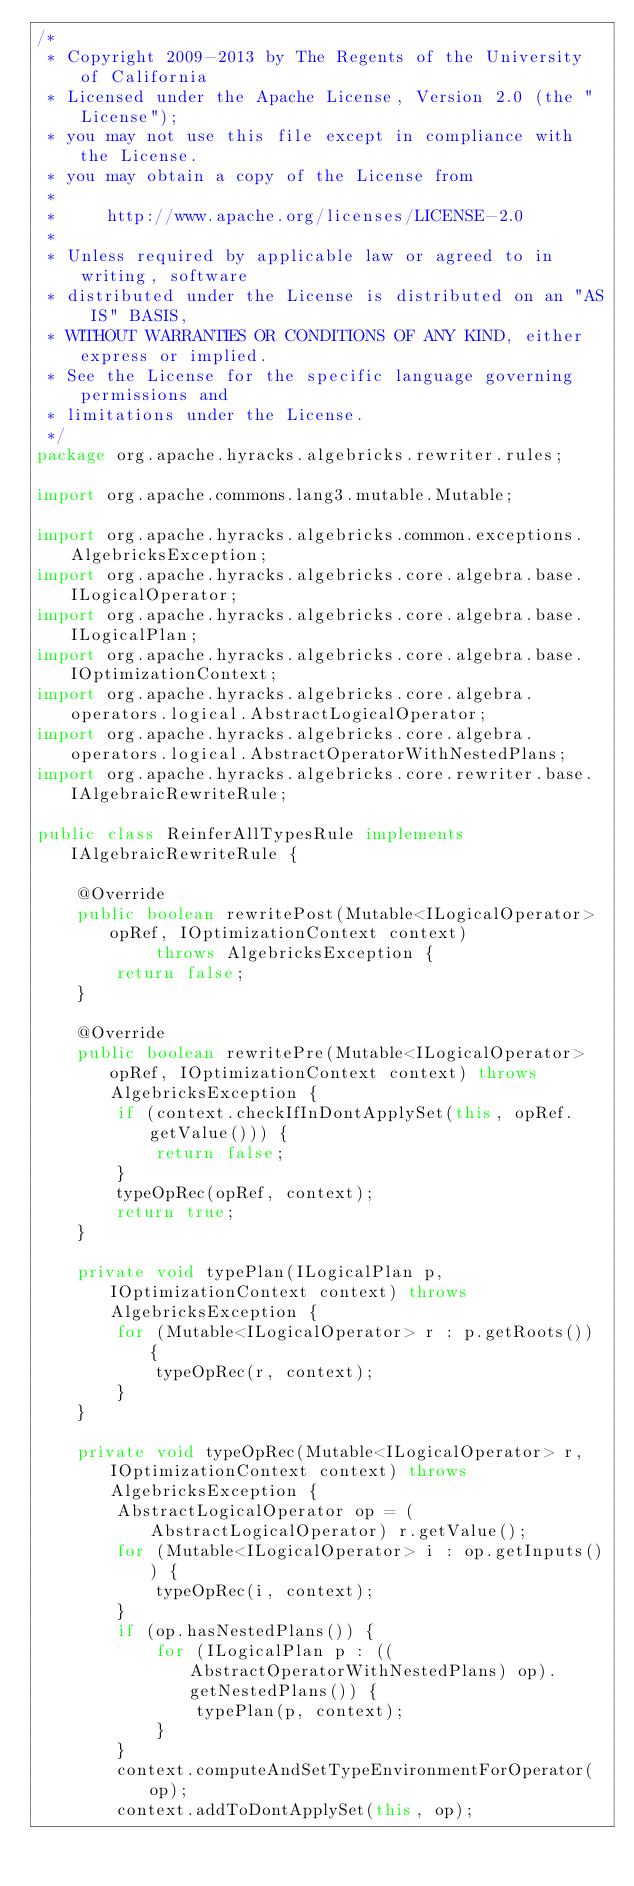Convert code to text. <code><loc_0><loc_0><loc_500><loc_500><_Java_>/*
 * Copyright 2009-2013 by The Regents of the University of California
 * Licensed under the Apache License, Version 2.0 (the "License");
 * you may not use this file except in compliance with the License.
 * you may obtain a copy of the License from
 * 
 *     http://www.apache.org/licenses/LICENSE-2.0
 * 
 * Unless required by applicable law or agreed to in writing, software
 * distributed under the License is distributed on an "AS IS" BASIS,
 * WITHOUT WARRANTIES OR CONDITIONS OF ANY KIND, either express or implied.
 * See the License for the specific language governing permissions and
 * limitations under the License.
 */
package org.apache.hyracks.algebricks.rewriter.rules;

import org.apache.commons.lang3.mutable.Mutable;

import org.apache.hyracks.algebricks.common.exceptions.AlgebricksException;
import org.apache.hyracks.algebricks.core.algebra.base.ILogicalOperator;
import org.apache.hyracks.algebricks.core.algebra.base.ILogicalPlan;
import org.apache.hyracks.algebricks.core.algebra.base.IOptimizationContext;
import org.apache.hyracks.algebricks.core.algebra.operators.logical.AbstractLogicalOperator;
import org.apache.hyracks.algebricks.core.algebra.operators.logical.AbstractOperatorWithNestedPlans;
import org.apache.hyracks.algebricks.core.rewriter.base.IAlgebraicRewriteRule;

public class ReinferAllTypesRule implements IAlgebraicRewriteRule {

    @Override
    public boolean rewritePost(Mutable<ILogicalOperator> opRef, IOptimizationContext context)
            throws AlgebricksException {
        return false;
    }

    @Override
    public boolean rewritePre(Mutable<ILogicalOperator> opRef, IOptimizationContext context) throws AlgebricksException {
        if (context.checkIfInDontApplySet(this, opRef.getValue())) {
            return false;
        }
        typeOpRec(opRef, context);
        return true;
    }

    private void typePlan(ILogicalPlan p, IOptimizationContext context) throws AlgebricksException {
        for (Mutable<ILogicalOperator> r : p.getRoots()) {
            typeOpRec(r, context);
        }
    }

    private void typeOpRec(Mutable<ILogicalOperator> r, IOptimizationContext context) throws AlgebricksException {
        AbstractLogicalOperator op = (AbstractLogicalOperator) r.getValue();
        for (Mutable<ILogicalOperator> i : op.getInputs()) {
            typeOpRec(i, context);
        }
        if (op.hasNestedPlans()) {
            for (ILogicalPlan p : ((AbstractOperatorWithNestedPlans) op).getNestedPlans()) {
                typePlan(p, context);
            }
        }
        context.computeAndSetTypeEnvironmentForOperator(op);
        context.addToDontApplySet(this, op);</code> 